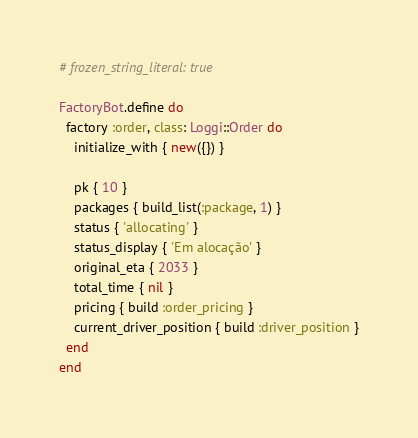Convert code to text. <code><loc_0><loc_0><loc_500><loc_500><_Ruby_># frozen_string_literal: true

FactoryBot.define do
  factory :order, class: Loggi::Order do
    initialize_with { new({}) }

    pk { 10 }
    packages { build_list(:package, 1) }
    status { 'allocating' }
    status_display { 'Em alocação' }
    original_eta { 2033 }
    total_time { nil }
    pricing { build :order_pricing }
    current_driver_position { build :driver_position }
  end
end
</code> 